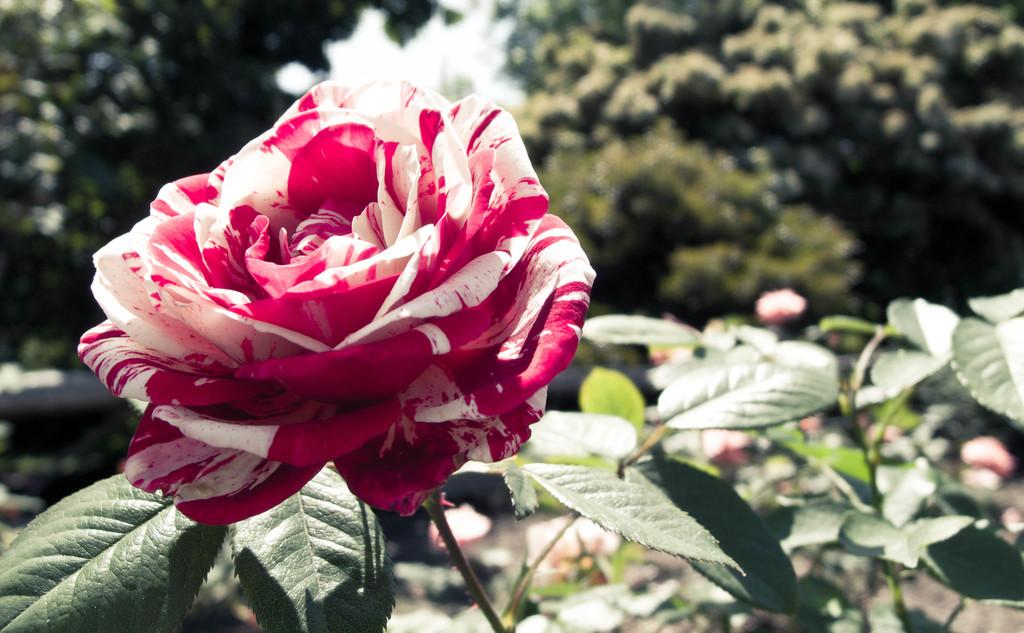What is the main subject in the front of the image? There is a flower in the front of the image. What else can be seen in the image besides the flower? There are leaves in the image. What is visible in the background of the image? There are trees in the background of the image. Where is the faucet located in the image? There is no faucet present in the image. What type of coil is wrapped around the tree in the image? There is no coil present in the image. 